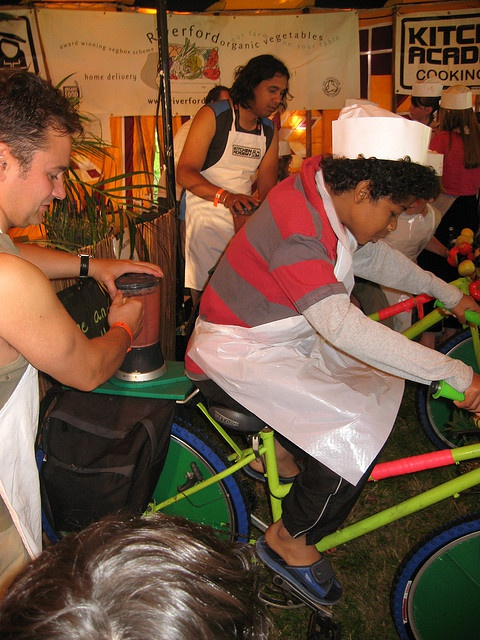Describe the objects in this image and their specific colors. I can see people in black, darkgray, and lightgray tones, people in black, salmon, and brown tones, bicycle in black, darkgreen, and olive tones, people in black, gray, maroon, and darkgray tones, and people in black, maroon, brown, and tan tones in this image. 